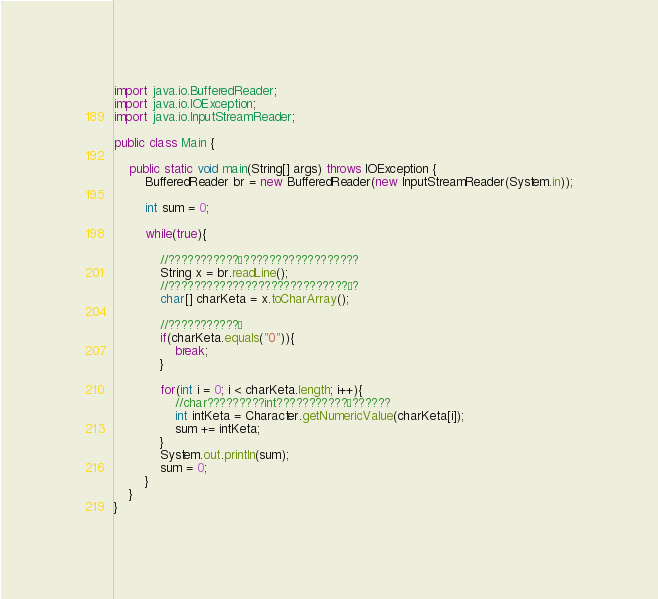Convert code to text. <code><loc_0><loc_0><loc_500><loc_500><_Java_>import java.io.BufferedReader;
import java.io.IOException;
import java.io.InputStreamReader;

public class Main {

    public static void main(String[] args) throws IOException {
        BufferedReader br = new BufferedReader(new InputStreamReader(System.in));

        int sum = 0;

        while(true){

            //???????????¨??????????????????
            String x = br.readLine();
            //????????????????????????????´?
            char[] charKeta = x.toCharArray();

            //???????????¶
            if(charKeta.equals("0")){
                break;
            }

            for(int i = 0; i < charKeta.length; i++){
                //char?????????int???????????£??????
                int intKeta = Character.getNumericValue(charKeta[i]);
                sum += intKeta;
            }
            System.out.println(sum);
            sum = 0;
        }
    }
}</code> 